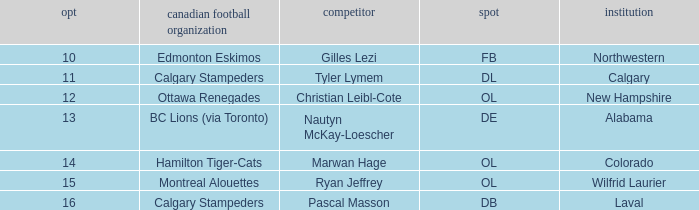What position does Christian Leibl-Cote play? OL. 